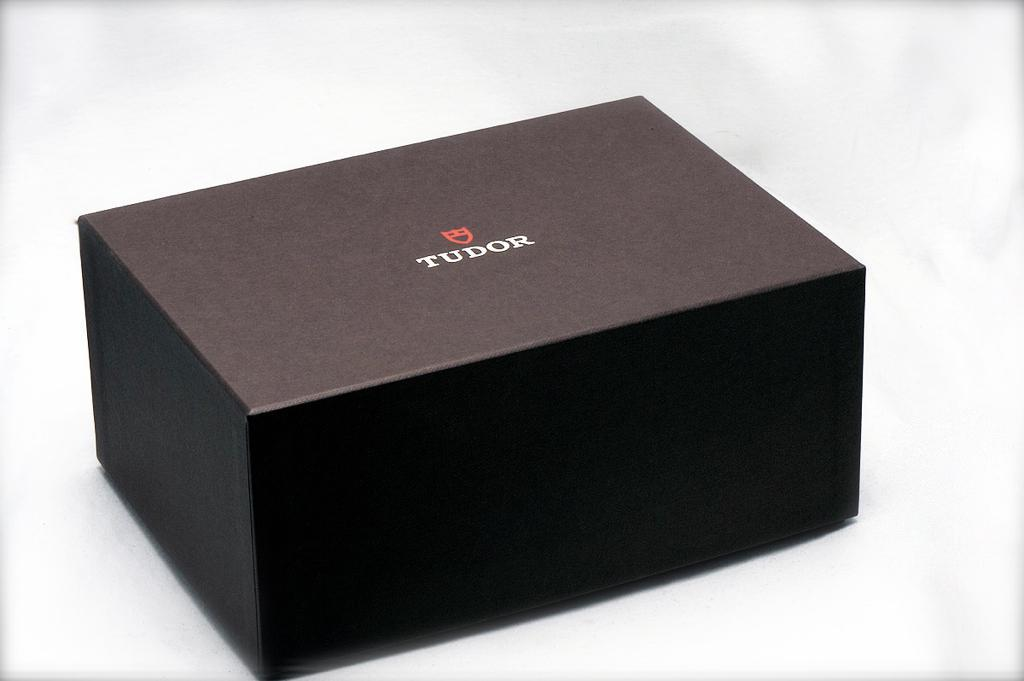<image>
Share a concise interpretation of the image provided. The word tudor is on a black box 